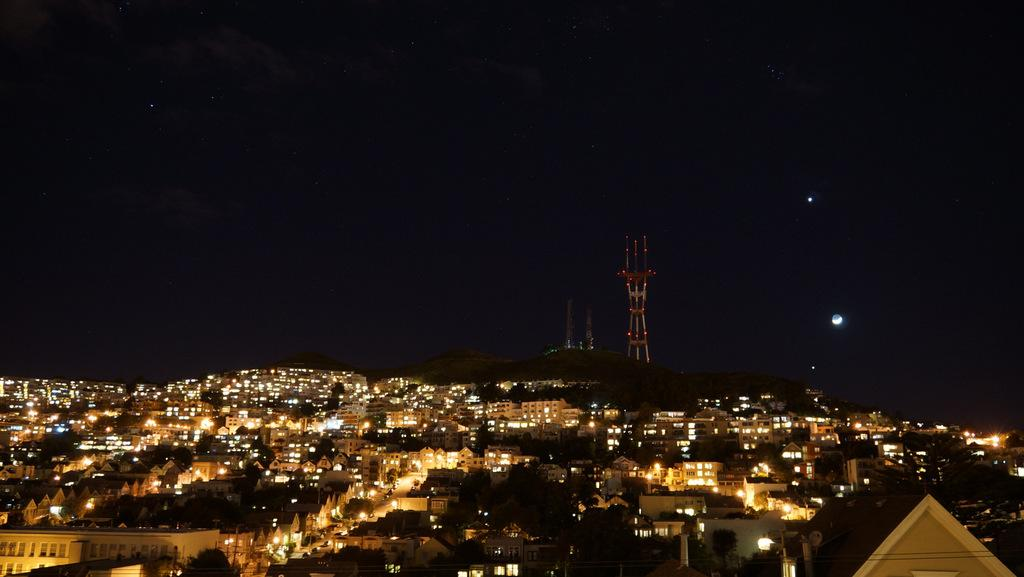What type of structures can be seen with lights in the image? There are buildings with lights in the image. What type of natural elements are present on the ground in the image? There are trees on the ground in the image. What can be seen on the mountain in the background of the image? There are towers on a mountain in the background of the image. What celestial objects are visible in the sky in the image? There is a moon visible in the sky, and there are stars visible in the sky. What type of wood is used to make the sofa in the image? There is no sofa present in the image; it features buildings, trees, towers, and celestial objects. What type of shoes can be seen on the people in the image? There are no people or shoes visible in the image. 